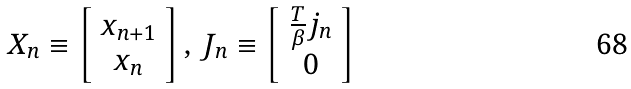Convert formula to latex. <formula><loc_0><loc_0><loc_500><loc_500>X _ { n } \equiv \left [ \begin{array} { c } { { x _ { n + 1 } } } \\ { { x _ { n } } } \end{array} \right ] , \, J _ { n } \equiv \left [ \begin{array} { c } { { \frac { T } { \beta } j _ { n } } } \\ { 0 } \end{array} \right ]</formula> 